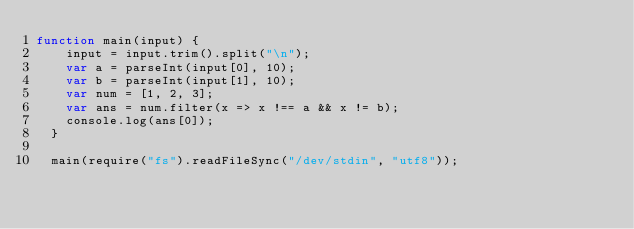<code> <loc_0><loc_0><loc_500><loc_500><_JavaScript_>function main(input) {
    input = input.trim().split("\n");
    var a = parseInt(input[0], 10);
    var b = parseInt(input[1], 10);
    var num = [1, 2, 3];
    var ans = num.filter(x => x !== a && x != b);
    console.log(ans[0]);
  }
   
  main(require("fs").readFileSync("/dev/stdin", "utf8"));</code> 